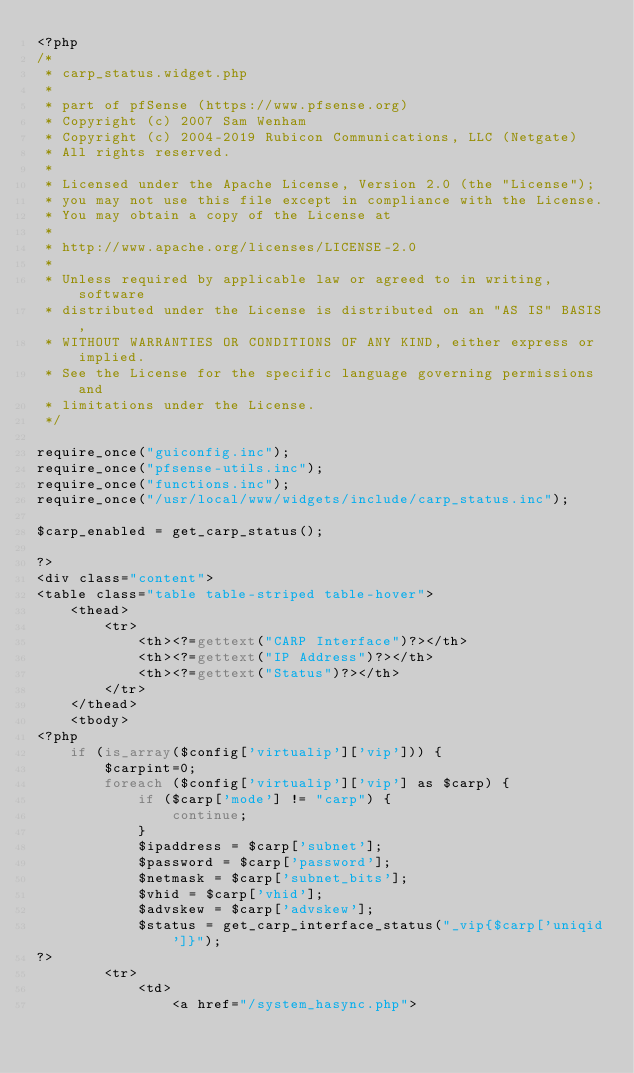Convert code to text. <code><loc_0><loc_0><loc_500><loc_500><_PHP_><?php
/*
 * carp_status.widget.php
 *
 * part of pfSense (https://www.pfsense.org)
 * Copyright (c) 2007 Sam Wenham
 * Copyright (c) 2004-2019 Rubicon Communications, LLC (Netgate)
 * All rights reserved.
 *
 * Licensed under the Apache License, Version 2.0 (the "License");
 * you may not use this file except in compliance with the License.
 * You may obtain a copy of the License at
 *
 * http://www.apache.org/licenses/LICENSE-2.0
 *
 * Unless required by applicable law or agreed to in writing, software
 * distributed under the License is distributed on an "AS IS" BASIS,
 * WITHOUT WARRANTIES OR CONDITIONS OF ANY KIND, either express or implied.
 * See the License for the specific language governing permissions and
 * limitations under the License.
 */

require_once("guiconfig.inc");
require_once("pfsense-utils.inc");
require_once("functions.inc");
require_once("/usr/local/www/widgets/include/carp_status.inc");

$carp_enabled = get_carp_status();

?>
<div class="content">
<table class="table table-striped table-hover">
	<thead>
		<tr>
			<th><?=gettext("CARP Interface")?></th>
			<th><?=gettext("IP Address")?></th>
			<th><?=gettext("Status")?></th>
		</tr>
	</thead>
	<tbody>
<?php
	if (is_array($config['virtualip']['vip'])) {
		$carpint=0;
		foreach ($config['virtualip']['vip'] as $carp) {
			if ($carp['mode'] != "carp") {
				continue;
			}
			$ipaddress = $carp['subnet'];
			$password = $carp['password'];
			$netmask = $carp['subnet_bits'];
			$vhid = $carp['vhid'];
			$advskew = $carp['advskew'];
			$status = get_carp_interface_status("_vip{$carp['uniqid']}");
?>
		<tr>
			<td>
				<a href="/system_hasync.php"></code> 